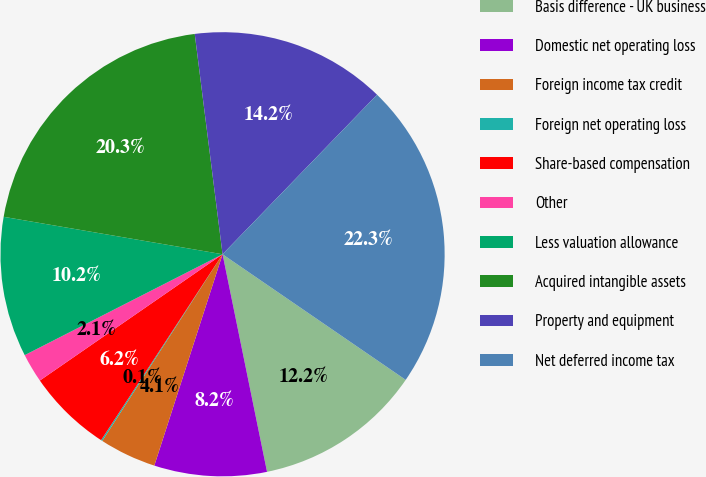<chart> <loc_0><loc_0><loc_500><loc_500><pie_chart><fcel>Basis difference - UK business<fcel>Domestic net operating loss<fcel>Foreign income tax credit<fcel>Foreign net operating loss<fcel>Share-based compensation<fcel>Other<fcel>Less valuation allowance<fcel>Acquired intangible assets<fcel>Property and equipment<fcel>Net deferred income tax<nl><fcel>12.22%<fcel>8.18%<fcel>4.14%<fcel>0.1%<fcel>6.16%<fcel>2.12%<fcel>10.2%<fcel>20.3%<fcel>14.24%<fcel>22.32%<nl></chart> 